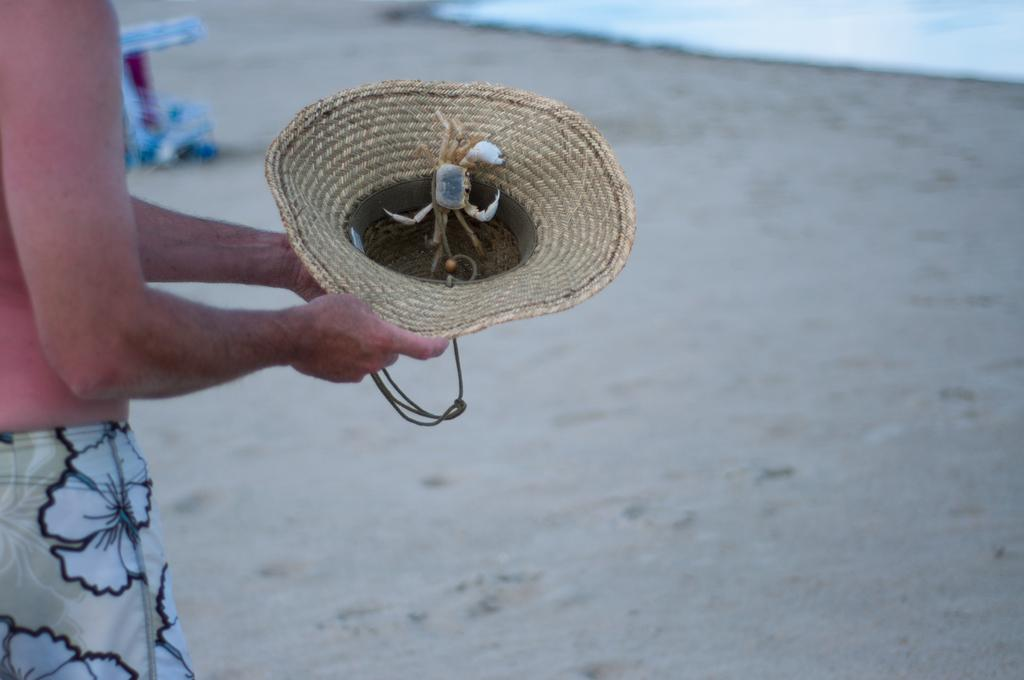What is the person in the image standing on? The person is standing on the sand in the image. What is the person holding in the image? The person is holding a hat in the image. What is inside the hat? There is a crab in the hat. What can be seen in the background of the image? There is an object in the background of the image. What is the condition of the water visible in the image? The provided facts do not mention the condition of the water, so we cannot answer this question definitively. What language is the person speaking in the image? The provided facts do not mention any speech or language, so we cannot answer this question definitively. 